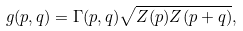Convert formula to latex. <formula><loc_0><loc_0><loc_500><loc_500>g ( p , q ) = \Gamma ( p , q ) \sqrt { Z ( p ) Z ( p + q ) } ,</formula> 